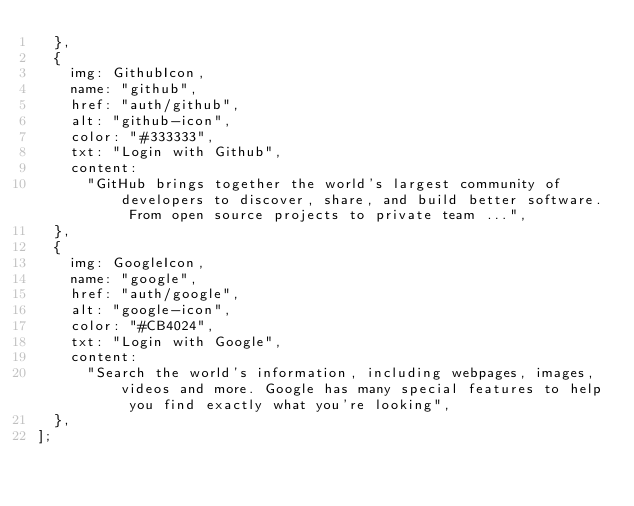Convert code to text. <code><loc_0><loc_0><loc_500><loc_500><_JavaScript_>  },
  {
    img: GithubIcon,
    name: "github",
    href: "auth/github",
    alt: "github-icon",
    color: "#333333",
    txt: "Login with Github",
    content:
      "GitHub brings together the world's largest community of developers to discover, share, and build better software. From open source projects to private team ...",
  },
  {
    img: GoogleIcon,
    name: "google",
    href: "auth/google",
    alt: "google-icon",
    color: "#CB4024",
    txt: "Login with Google",
    content:
      "Search the world's information, including webpages, images, videos and more. Google has many special features to help you find exactly what you're looking",
  },
];
</code> 